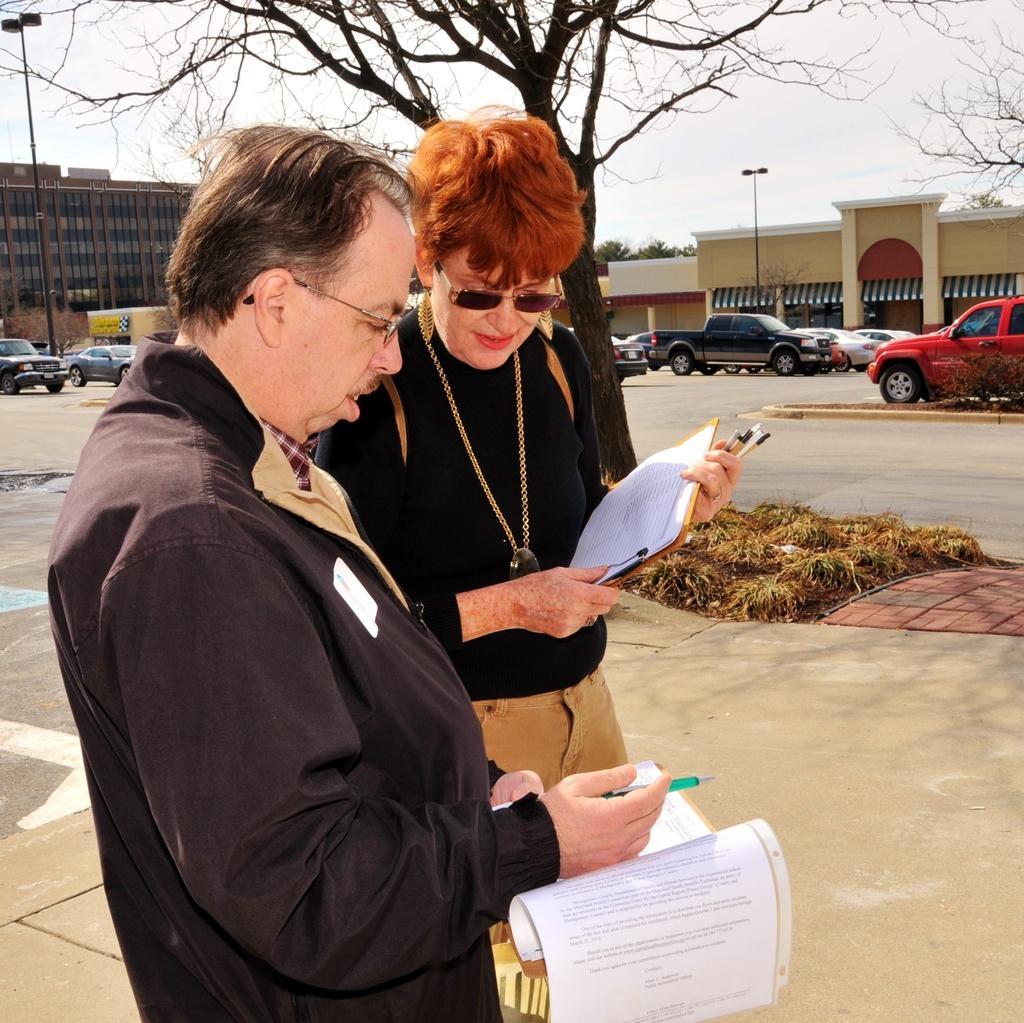Describe this image in one or two sentences. In this image I can see two persons standing and they are holding few papers, background I can see few vehicles, light poles, buildings in brown and cream color and the sky is in white color. 